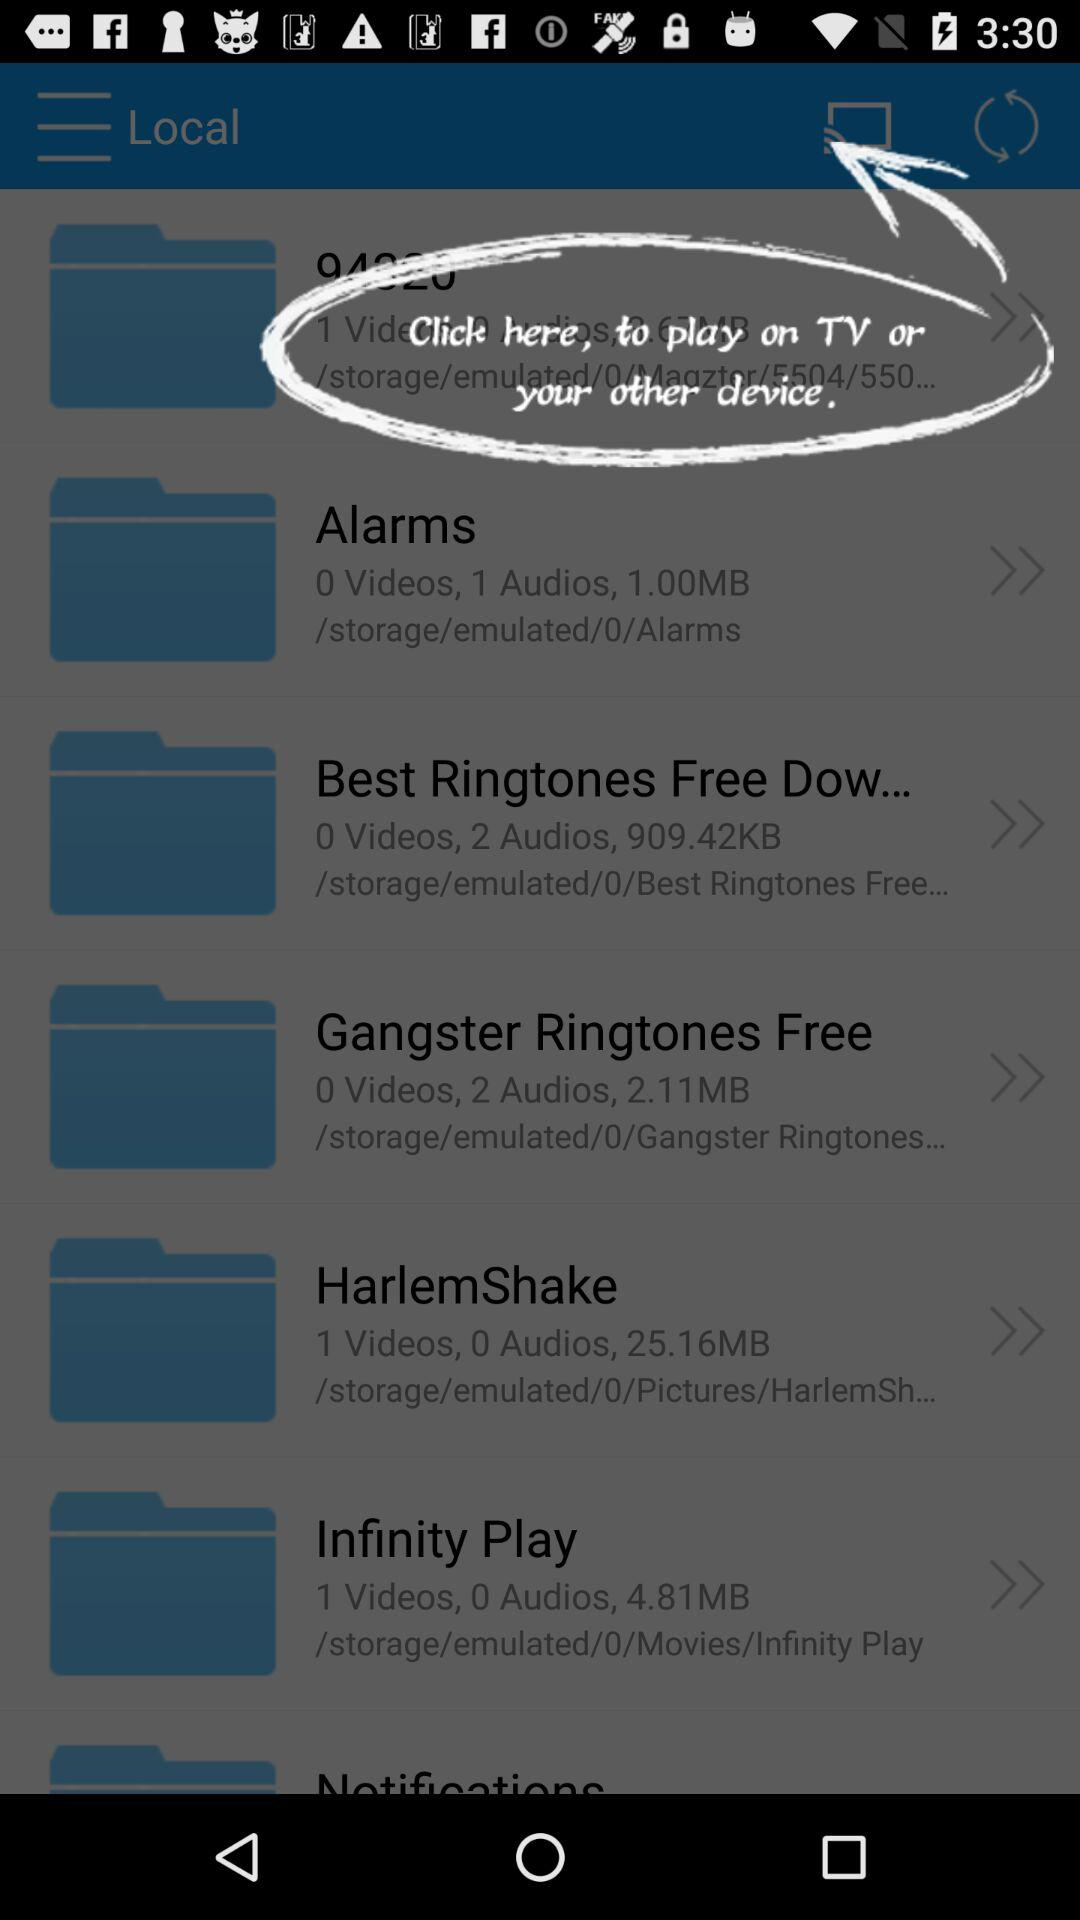What is the number of videos in "Alarms"? The number of videos is 0 in alarms. 